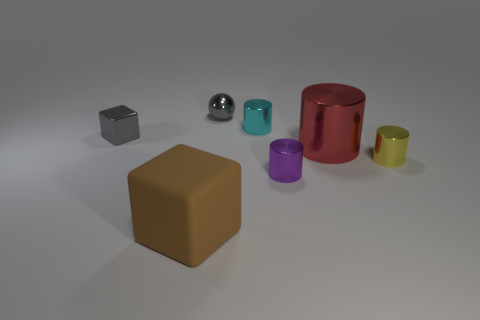Is there anything else that has the same material as the large brown block?
Your answer should be compact. No. Are there more tiny cylinders behind the small yellow metal thing than big blue metal cylinders?
Offer a very short reply. Yes. There is a gray shiny ball; are there any tiny objects left of it?
Your answer should be compact. Yes. Do the cyan cylinder and the red metal cylinder have the same size?
Offer a terse response. No. There is another object that is the same shape as the rubber object; what size is it?
Your answer should be compact. Small. Are there any other things that are the same size as the brown cube?
Provide a short and direct response. Yes. The cube behind the yellow metal cylinder that is right of the brown object is made of what material?
Your response must be concise. Metal. Is the shape of the brown thing the same as the small cyan metallic object?
Provide a succinct answer. No. How many gray metallic objects are both on the left side of the large rubber thing and to the right of the brown matte object?
Provide a short and direct response. 0. Is the number of yellow objects behind the small purple shiny cylinder the same as the number of gray metallic blocks that are in front of the shiny block?
Ensure brevity in your answer.  No. 